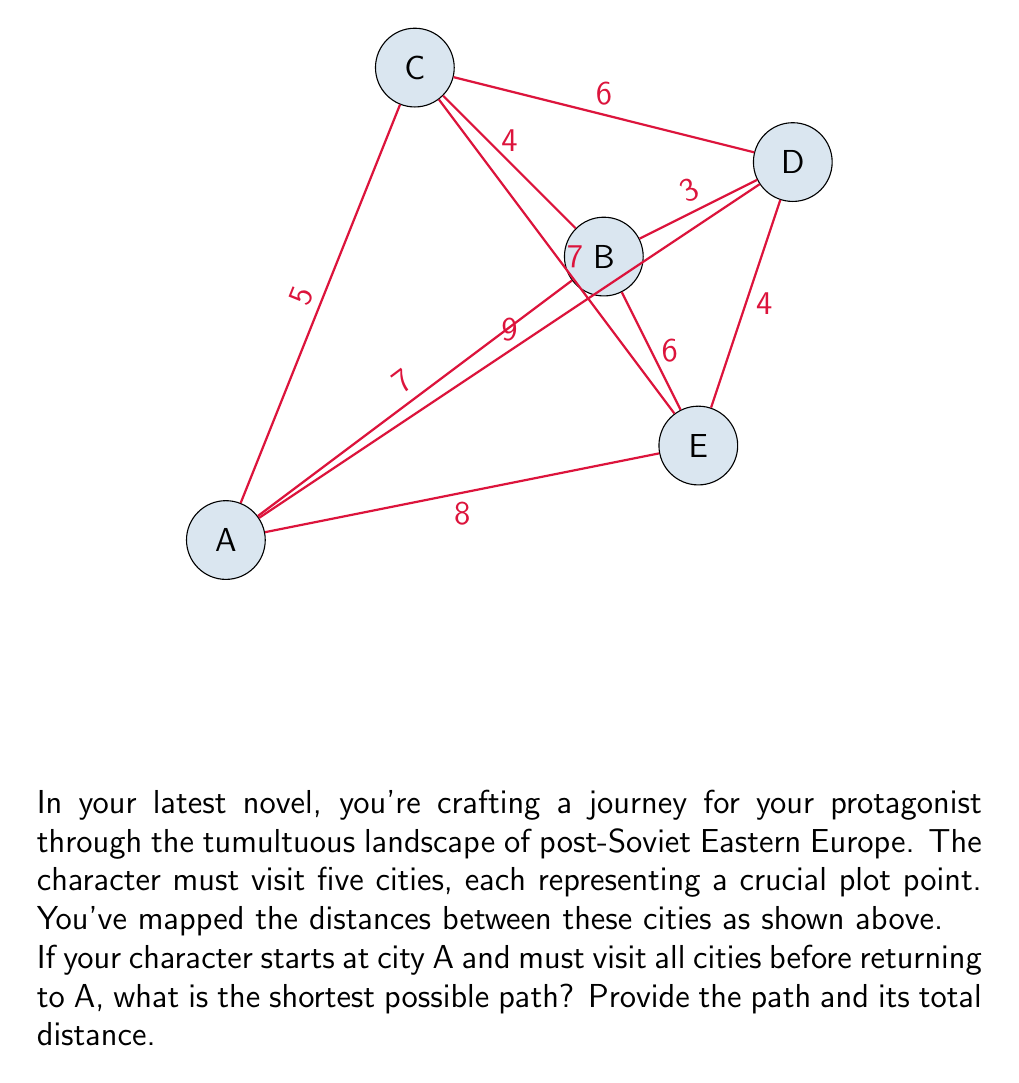Teach me how to tackle this problem. To solve this problem, we need to find the shortest Hamiltonian cycle in the given graph, which is known as the Traveling Salesman Problem (TSP). For a small graph like this, we can use a brute-force approach to find the optimal solution.

Step 1: List all possible Hamiltonian cycles starting and ending at A.
There are $(5-1)! = 24$ possible cycles.

Step 2: Calculate the length of each cycle. Here are a few examples:
A-B-C-D-E-A: $7 + 4 + 6 + 4 + 8 = 29$
A-B-C-E-D-A: $7 + 4 + 7 + 4 + 9 = 31$
A-B-D-C-E-A: $7 + 3 + 6 + 7 + 8 = 31$
...

Step 3: Identify the shortest cycle.
After calculating all 24 cycles, we find that the shortest cycle is:
A-B-D-E-C-A with a total distance of $7 + 3 + 4 + 7 + 5 = 26$

This path represents the optimal route for the character's journey, visiting each city once and returning to the starting point with the minimum total distance traveled.

The complexity of this brute-force approach is $O(n!)$, where $n$ is the number of cities. For larger graphs, more efficient algorithms like dynamic programming or approximation algorithms would be necessary.
Answer: Path: A-B-D-E-C-A, Distance: 26 